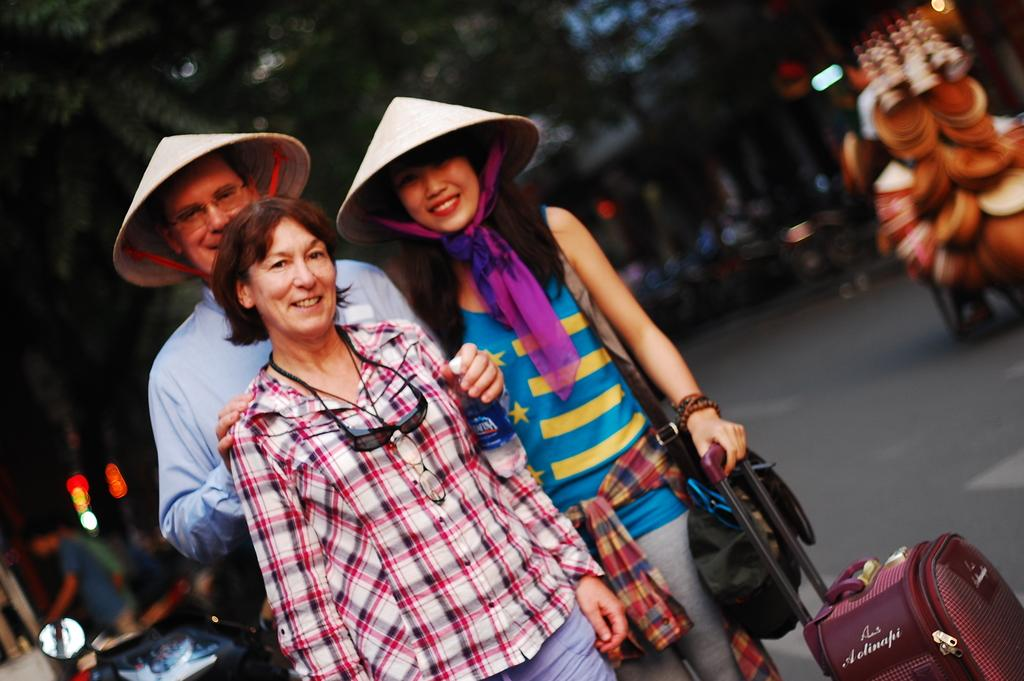Who or what can be seen in the image? There are people in the image. What object is located on the right side of the image? There is a briefcase on the right side of the image. What can be seen in the distance in the image? There are vehicles and trees visible in the background of the image. How many snails can be seen crawling on the briefcase in the image? There are no snails visible on the briefcase in the image. What type of school is depicted in the background of the image? There is no school present in the image; it features vehicles and trees in the background. 